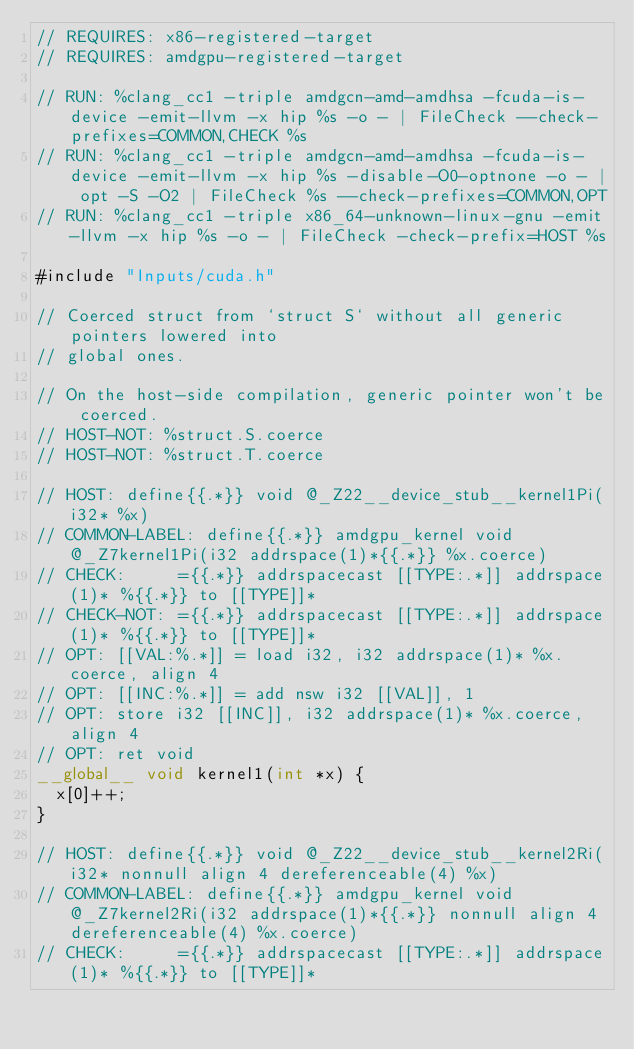<code> <loc_0><loc_0><loc_500><loc_500><_Cuda_>// REQUIRES: x86-registered-target
// REQUIRES: amdgpu-registered-target

// RUN: %clang_cc1 -triple amdgcn-amd-amdhsa -fcuda-is-device -emit-llvm -x hip %s -o - | FileCheck --check-prefixes=COMMON,CHECK %s
// RUN: %clang_cc1 -triple amdgcn-amd-amdhsa -fcuda-is-device -emit-llvm -x hip %s -disable-O0-optnone -o - | opt -S -O2 | FileCheck %s --check-prefixes=COMMON,OPT
// RUN: %clang_cc1 -triple x86_64-unknown-linux-gnu -emit-llvm -x hip %s -o - | FileCheck -check-prefix=HOST %s

#include "Inputs/cuda.h"

// Coerced struct from `struct S` without all generic pointers lowered into
// global ones.

// On the host-side compilation, generic pointer won't be coerced.
// HOST-NOT: %struct.S.coerce
// HOST-NOT: %struct.T.coerce

// HOST: define{{.*}} void @_Z22__device_stub__kernel1Pi(i32* %x)
// COMMON-LABEL: define{{.*}} amdgpu_kernel void @_Z7kernel1Pi(i32 addrspace(1)*{{.*}} %x.coerce)
// CHECK:     ={{.*}} addrspacecast [[TYPE:.*]] addrspace(1)* %{{.*}} to [[TYPE]]*
// CHECK-NOT: ={{.*}} addrspacecast [[TYPE:.*]] addrspace(1)* %{{.*}} to [[TYPE]]*
// OPT: [[VAL:%.*]] = load i32, i32 addrspace(1)* %x.coerce, align 4
// OPT: [[INC:%.*]] = add nsw i32 [[VAL]], 1
// OPT: store i32 [[INC]], i32 addrspace(1)* %x.coerce, align 4
// OPT: ret void
__global__ void kernel1(int *x) {
  x[0]++;
}

// HOST: define{{.*}} void @_Z22__device_stub__kernel2Ri(i32* nonnull align 4 dereferenceable(4) %x)
// COMMON-LABEL: define{{.*}} amdgpu_kernel void @_Z7kernel2Ri(i32 addrspace(1)*{{.*}} nonnull align 4 dereferenceable(4) %x.coerce)
// CHECK:     ={{.*}} addrspacecast [[TYPE:.*]] addrspace(1)* %{{.*}} to [[TYPE]]*</code> 